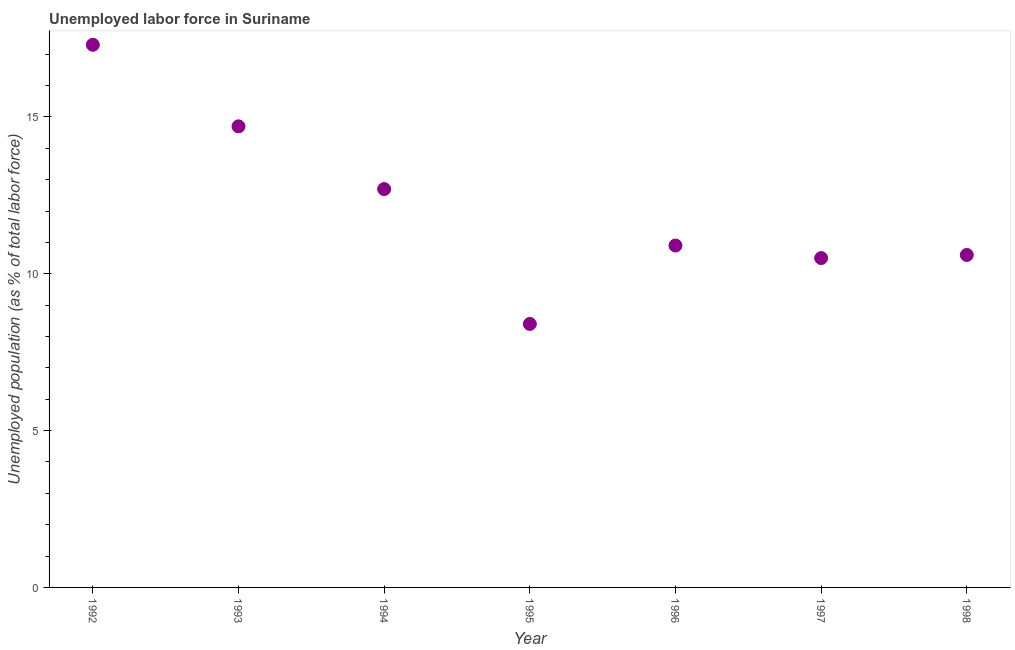What is the total unemployed population in 1993?
Ensure brevity in your answer.  14.7. Across all years, what is the maximum total unemployed population?
Offer a very short reply. 17.3. Across all years, what is the minimum total unemployed population?
Ensure brevity in your answer.  8.4. In which year was the total unemployed population maximum?
Ensure brevity in your answer.  1992. In which year was the total unemployed population minimum?
Provide a succinct answer. 1995. What is the sum of the total unemployed population?
Provide a short and direct response. 85.1. What is the difference between the total unemployed population in 1993 and 1997?
Provide a short and direct response. 4.2. What is the average total unemployed population per year?
Give a very brief answer. 12.16. What is the median total unemployed population?
Ensure brevity in your answer.  10.9. In how many years, is the total unemployed population greater than 5 %?
Offer a very short reply. 7. What is the ratio of the total unemployed population in 1992 to that in 1997?
Give a very brief answer. 1.65. Is the total unemployed population in 1995 less than that in 1996?
Your response must be concise. Yes. Is the difference between the total unemployed population in 1994 and 1998 greater than the difference between any two years?
Your answer should be compact. No. What is the difference between the highest and the second highest total unemployed population?
Keep it short and to the point. 2.6. What is the difference between the highest and the lowest total unemployed population?
Make the answer very short. 8.9. How many years are there in the graph?
Your answer should be compact. 7. Are the values on the major ticks of Y-axis written in scientific E-notation?
Provide a succinct answer. No. Does the graph contain any zero values?
Offer a very short reply. No. What is the title of the graph?
Your answer should be very brief. Unemployed labor force in Suriname. What is the label or title of the X-axis?
Make the answer very short. Year. What is the label or title of the Y-axis?
Provide a succinct answer. Unemployed population (as % of total labor force). What is the Unemployed population (as % of total labor force) in 1992?
Make the answer very short. 17.3. What is the Unemployed population (as % of total labor force) in 1993?
Provide a short and direct response. 14.7. What is the Unemployed population (as % of total labor force) in 1994?
Provide a succinct answer. 12.7. What is the Unemployed population (as % of total labor force) in 1995?
Make the answer very short. 8.4. What is the Unemployed population (as % of total labor force) in 1996?
Provide a succinct answer. 10.9. What is the Unemployed population (as % of total labor force) in 1998?
Your answer should be compact. 10.6. What is the difference between the Unemployed population (as % of total labor force) in 1992 and 1997?
Ensure brevity in your answer.  6.8. What is the difference between the Unemployed population (as % of total labor force) in 1993 and 1997?
Offer a terse response. 4.2. What is the difference between the Unemployed population (as % of total labor force) in 1993 and 1998?
Give a very brief answer. 4.1. What is the difference between the Unemployed population (as % of total labor force) in 1994 and 1995?
Provide a succinct answer. 4.3. What is the difference between the Unemployed population (as % of total labor force) in 1994 and 1996?
Make the answer very short. 1.8. What is the difference between the Unemployed population (as % of total labor force) in 1994 and 1997?
Provide a short and direct response. 2.2. What is the difference between the Unemployed population (as % of total labor force) in 1994 and 1998?
Your response must be concise. 2.1. What is the difference between the Unemployed population (as % of total labor force) in 1996 and 1997?
Offer a very short reply. 0.4. What is the difference between the Unemployed population (as % of total labor force) in 1997 and 1998?
Keep it short and to the point. -0.1. What is the ratio of the Unemployed population (as % of total labor force) in 1992 to that in 1993?
Offer a very short reply. 1.18. What is the ratio of the Unemployed population (as % of total labor force) in 1992 to that in 1994?
Provide a short and direct response. 1.36. What is the ratio of the Unemployed population (as % of total labor force) in 1992 to that in 1995?
Your answer should be very brief. 2.06. What is the ratio of the Unemployed population (as % of total labor force) in 1992 to that in 1996?
Provide a succinct answer. 1.59. What is the ratio of the Unemployed population (as % of total labor force) in 1992 to that in 1997?
Ensure brevity in your answer.  1.65. What is the ratio of the Unemployed population (as % of total labor force) in 1992 to that in 1998?
Make the answer very short. 1.63. What is the ratio of the Unemployed population (as % of total labor force) in 1993 to that in 1994?
Provide a short and direct response. 1.16. What is the ratio of the Unemployed population (as % of total labor force) in 1993 to that in 1995?
Offer a very short reply. 1.75. What is the ratio of the Unemployed population (as % of total labor force) in 1993 to that in 1996?
Your response must be concise. 1.35. What is the ratio of the Unemployed population (as % of total labor force) in 1993 to that in 1997?
Make the answer very short. 1.4. What is the ratio of the Unemployed population (as % of total labor force) in 1993 to that in 1998?
Your answer should be very brief. 1.39. What is the ratio of the Unemployed population (as % of total labor force) in 1994 to that in 1995?
Give a very brief answer. 1.51. What is the ratio of the Unemployed population (as % of total labor force) in 1994 to that in 1996?
Keep it short and to the point. 1.17. What is the ratio of the Unemployed population (as % of total labor force) in 1994 to that in 1997?
Offer a very short reply. 1.21. What is the ratio of the Unemployed population (as % of total labor force) in 1994 to that in 1998?
Your answer should be compact. 1.2. What is the ratio of the Unemployed population (as % of total labor force) in 1995 to that in 1996?
Give a very brief answer. 0.77. What is the ratio of the Unemployed population (as % of total labor force) in 1995 to that in 1997?
Give a very brief answer. 0.8. What is the ratio of the Unemployed population (as % of total labor force) in 1995 to that in 1998?
Make the answer very short. 0.79. What is the ratio of the Unemployed population (as % of total labor force) in 1996 to that in 1997?
Your response must be concise. 1.04. What is the ratio of the Unemployed population (as % of total labor force) in 1996 to that in 1998?
Provide a succinct answer. 1.03. 